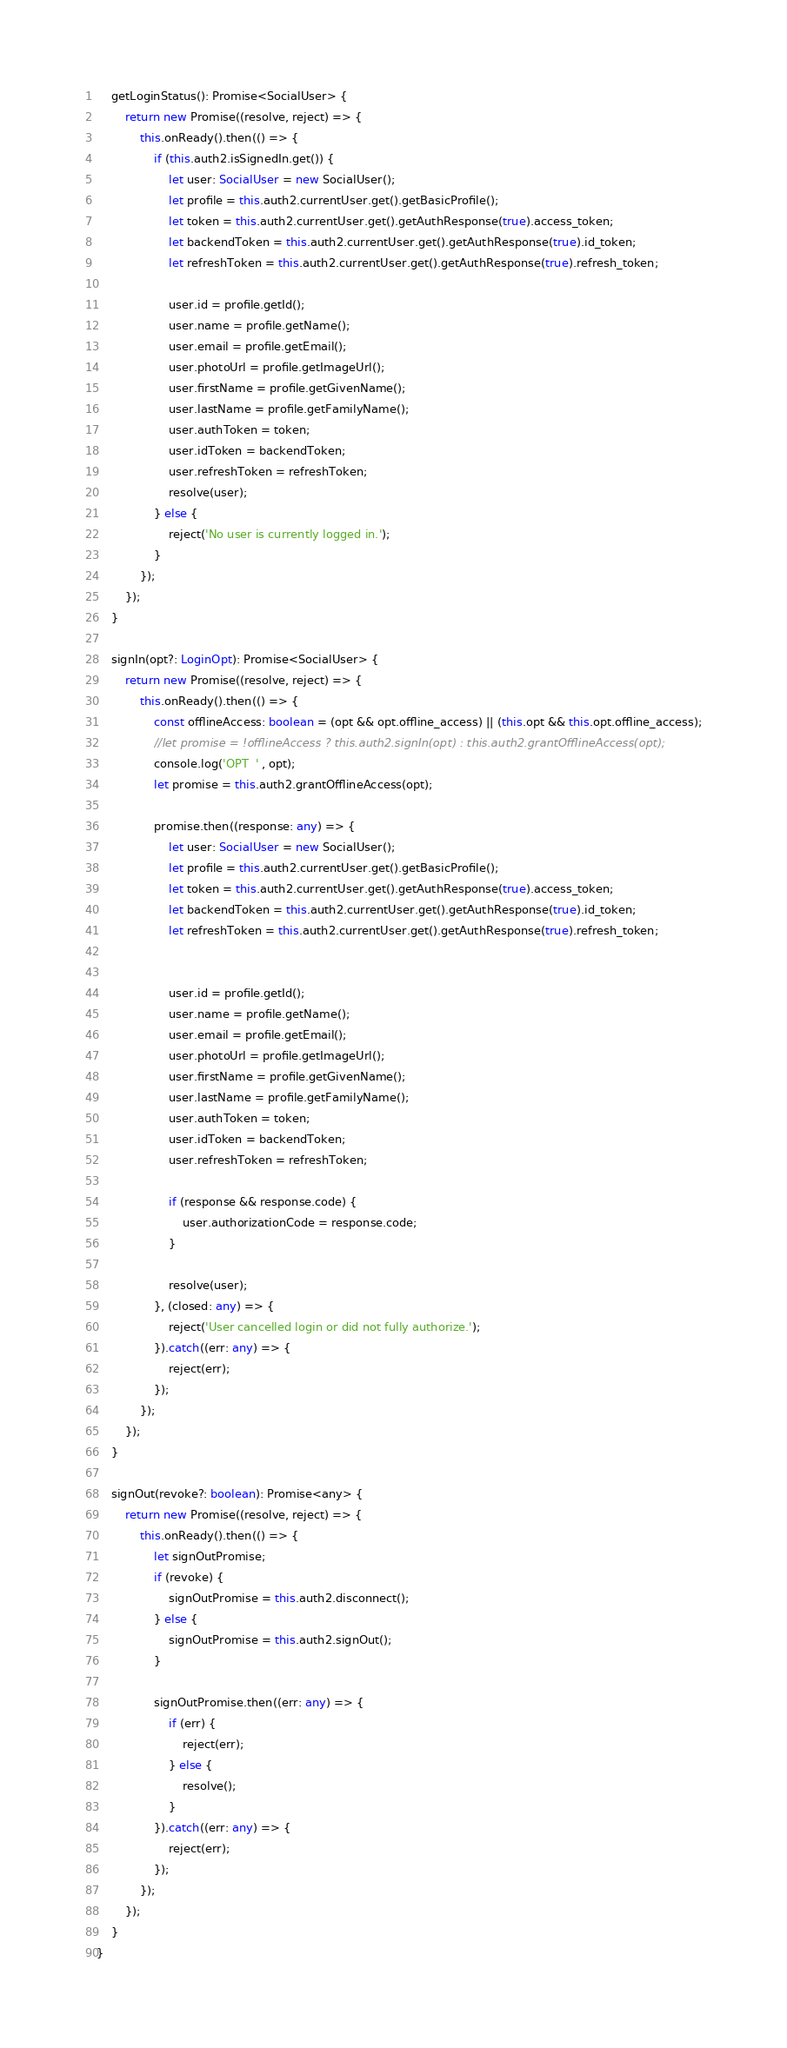Convert code to text. <code><loc_0><loc_0><loc_500><loc_500><_TypeScript_>
    getLoginStatus(): Promise<SocialUser> {
        return new Promise((resolve, reject) => {
            this.onReady().then(() => {
                if (this.auth2.isSignedIn.get()) {
                    let user: SocialUser = new SocialUser();
                    let profile = this.auth2.currentUser.get().getBasicProfile();
                    let token = this.auth2.currentUser.get().getAuthResponse(true).access_token;
                    let backendToken = this.auth2.currentUser.get().getAuthResponse(true).id_token;
                    let refreshToken = this.auth2.currentUser.get().getAuthResponse(true).refresh_token;

                    user.id = profile.getId();
                    user.name = profile.getName();
                    user.email = profile.getEmail();
                    user.photoUrl = profile.getImageUrl();
                    user.firstName = profile.getGivenName();
                    user.lastName = profile.getFamilyName();
                    user.authToken = token;
                    user.idToken = backendToken;
                    user.refreshToken = refreshToken;
                    resolve(user);
                } else {
                    reject('No user is currently logged in.');
                }
            });
        });
    }

    signIn(opt?: LoginOpt): Promise<SocialUser> {
        return new Promise((resolve, reject) => {
            this.onReady().then(() => {
                const offlineAccess: boolean = (opt && opt.offline_access) || (this.opt && this.opt.offline_access);
                //let promise = !offlineAccess ? this.auth2.signIn(opt) : this.auth2.grantOfflineAccess(opt);
                console.log('OPT  ' , opt);
                let promise = this.auth2.grantOfflineAccess(opt);

                promise.then((response: any) => {
                    let user: SocialUser = new SocialUser();
                    let profile = this.auth2.currentUser.get().getBasicProfile();
                    let token = this.auth2.currentUser.get().getAuthResponse(true).access_token;
                    let backendToken = this.auth2.currentUser.get().getAuthResponse(true).id_token;
                    let refreshToken = this.auth2.currentUser.get().getAuthResponse(true).refresh_token;


                    user.id = profile.getId();
                    user.name = profile.getName();
                    user.email = profile.getEmail();
                    user.photoUrl = profile.getImageUrl();
                    user.firstName = profile.getGivenName();
                    user.lastName = profile.getFamilyName();
                    user.authToken = token;
                    user.idToken = backendToken;
                    user.refreshToken = refreshToken;

                    if (response && response.code) {
                        user.authorizationCode = response.code;
                    }

                    resolve(user);
                }, (closed: any) => {
                    reject('User cancelled login or did not fully authorize.');
                }).catch((err: any) => {
                    reject(err);
                });
            });
        });
    }

    signOut(revoke?: boolean): Promise<any> {
        return new Promise((resolve, reject) => {
            this.onReady().then(() => {
                let signOutPromise;
                if (revoke) {
                    signOutPromise = this.auth2.disconnect();
                } else {
                    signOutPromise = this.auth2.signOut();
                }

                signOutPromise.then((err: any) => {
                    if (err) {
                        reject(err);
                    } else {
                        resolve();
                    }
                }).catch((err: any) => {
                    reject(err);
                });
            });
        });
    }
}
</code> 